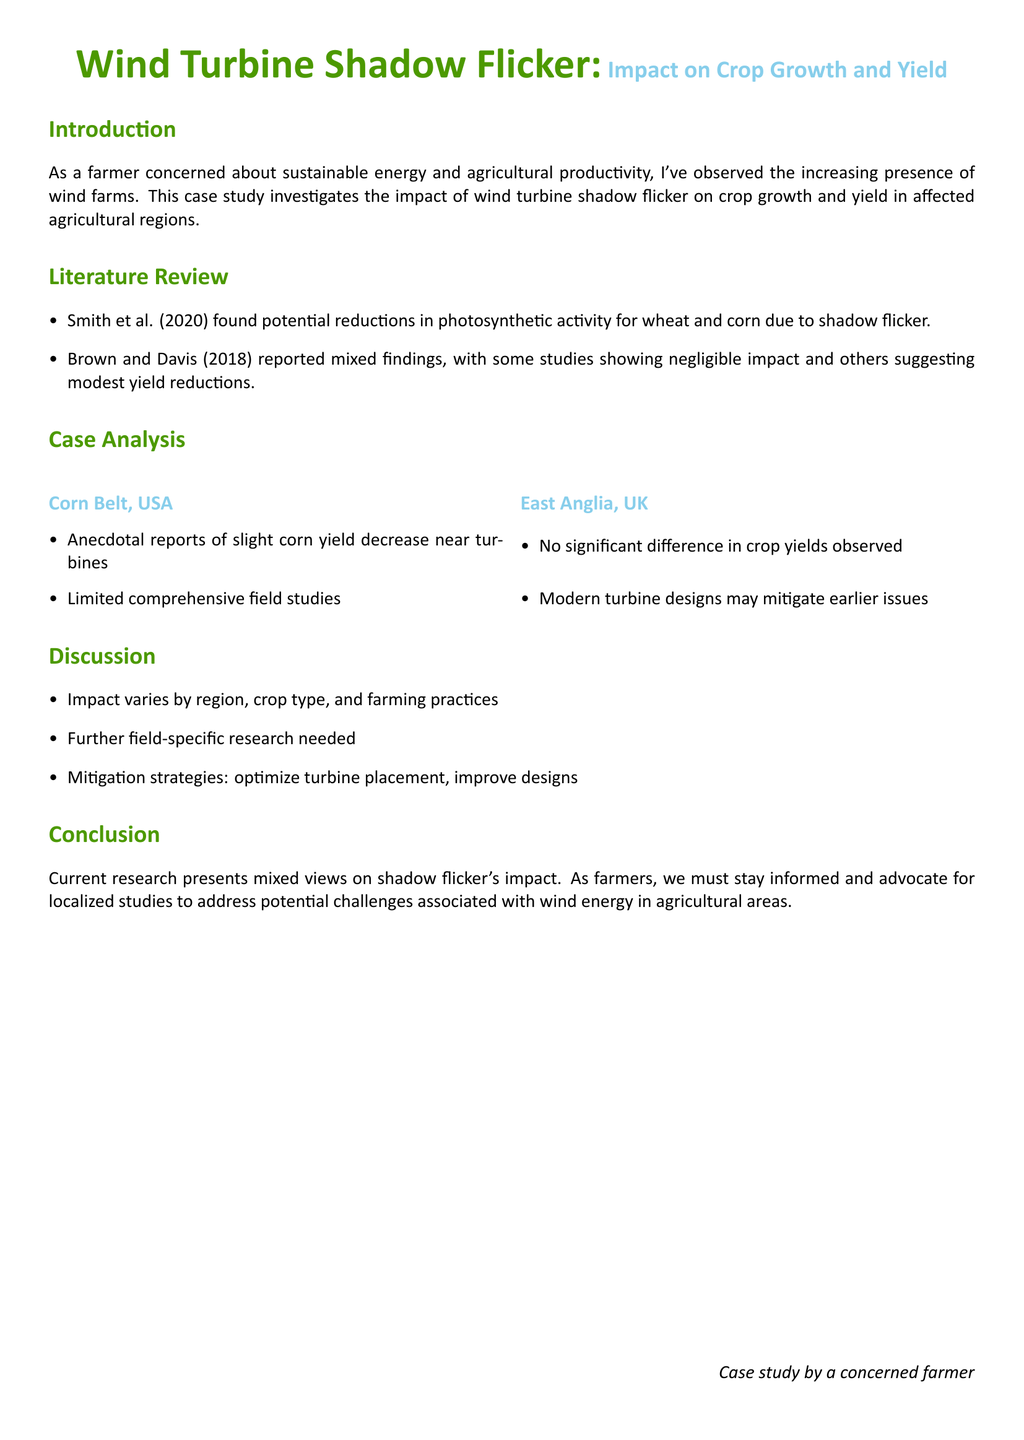What is the title of the case study? The title is located at the beginning of the document and indicates the study's focus.
Answer: Wind Turbine Shadow Flicker: Impact on Crop Growth and Yield Who conducted the research that found potential reductions in photosynthetic activity? This information is found in the literature review and identifies the researchers involved in the study.
Answer: Smith et al. (2020) What region is mentioned as having anecdotal reports of corn yield decrease? The case analysis provides specific regions studied for yield impacts, highlighting one with anecdotal evidence.
Answer: Corn Belt, USA What crop type was mentioned in mixed findings regarding yield impact? The literature review discusses various crops, including one that showed mixed yield impact findings.
Answer: Corn What mitigation strategy is suggested in the discussion section? The discussion contains recommendations for addressing shadow flicker impacts, focusing on turbine management.
Answer: Optimize turbine placement What year is associated with the report of mixed findings by Brown and Davis? This detail is specified in the literature review, assigning a publication year to the findings.
Answer: 2018 How many regions were analyzed in the case study? The case analysis mentions two distinct geographical areas considered in the study.
Answer: Two What is described as potentially decreasing due to shadow flicker? The introduction outlines the main concern related to agricultural productivity affected by wind farm operations.
Answer: Crop growth and yield 